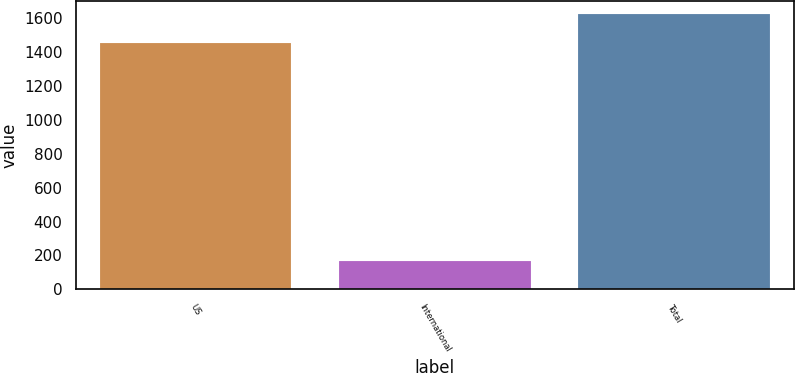Convert chart to OTSL. <chart><loc_0><loc_0><loc_500><loc_500><bar_chart><fcel>US<fcel>International<fcel>Total<nl><fcel>1455<fcel>169<fcel>1624<nl></chart> 